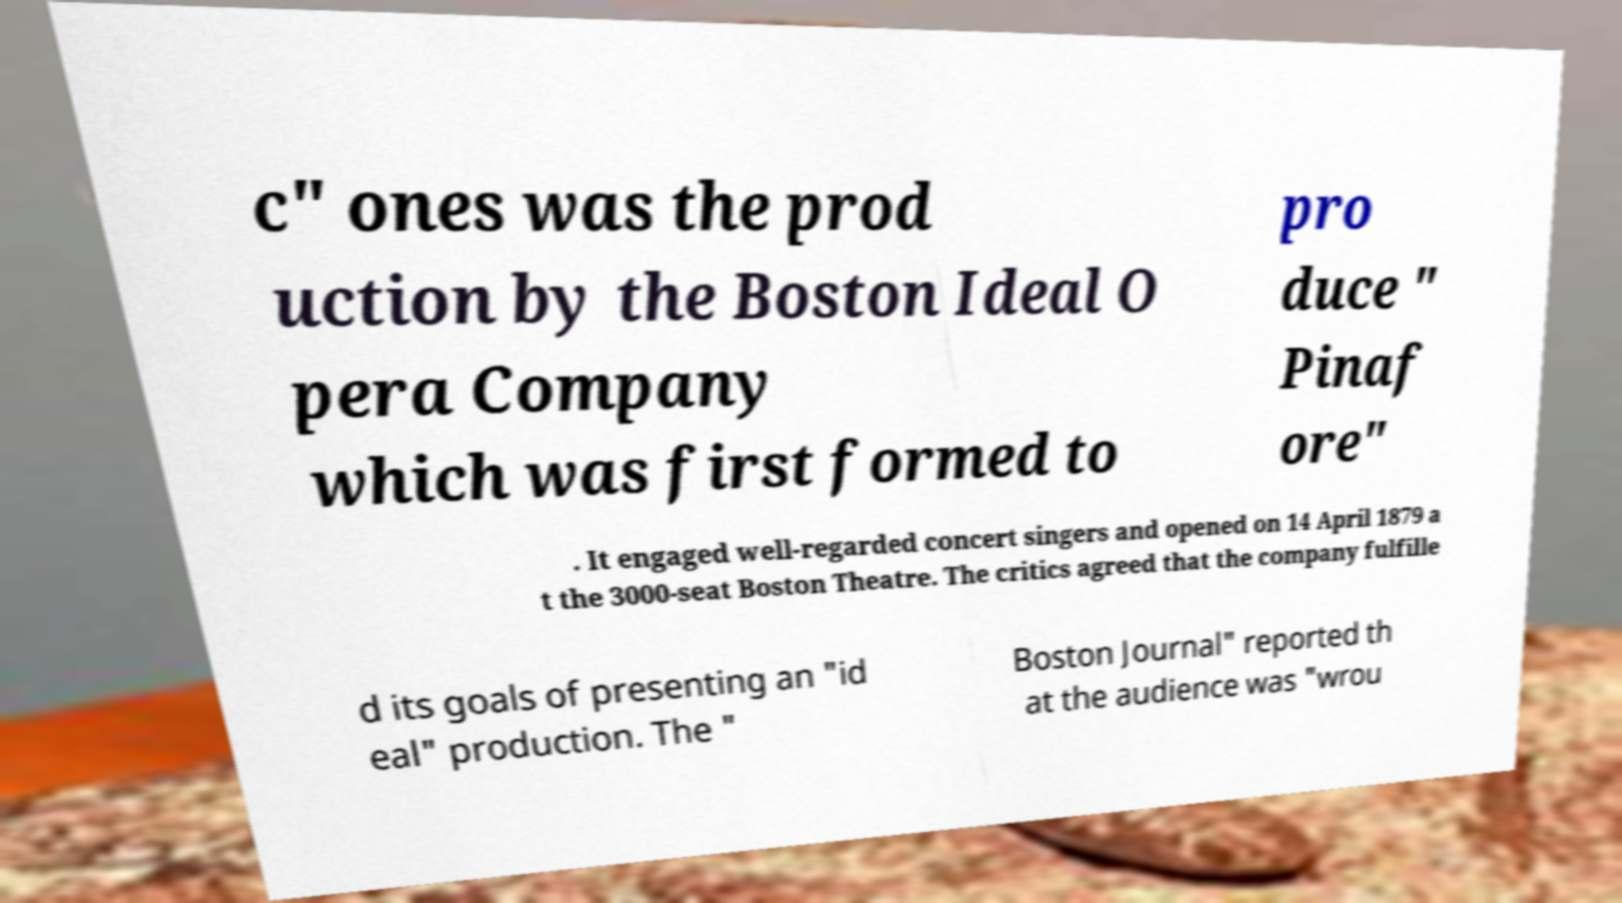There's text embedded in this image that I need extracted. Can you transcribe it verbatim? c" ones was the prod uction by the Boston Ideal O pera Company which was first formed to pro duce " Pinaf ore" . It engaged well-regarded concert singers and opened on 14 April 1879 a t the 3000-seat Boston Theatre. The critics agreed that the company fulfille d its goals of presenting an "id eal" production. The " Boston Journal" reported th at the audience was "wrou 